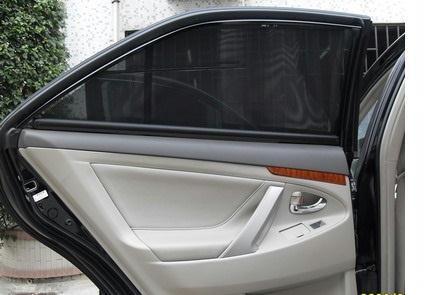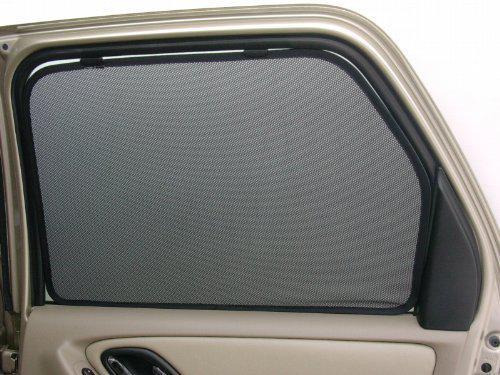The first image is the image on the left, the second image is the image on the right. Examine the images to the left and right. Is the description "The door of the car is open." accurate? Answer yes or no. Yes. 